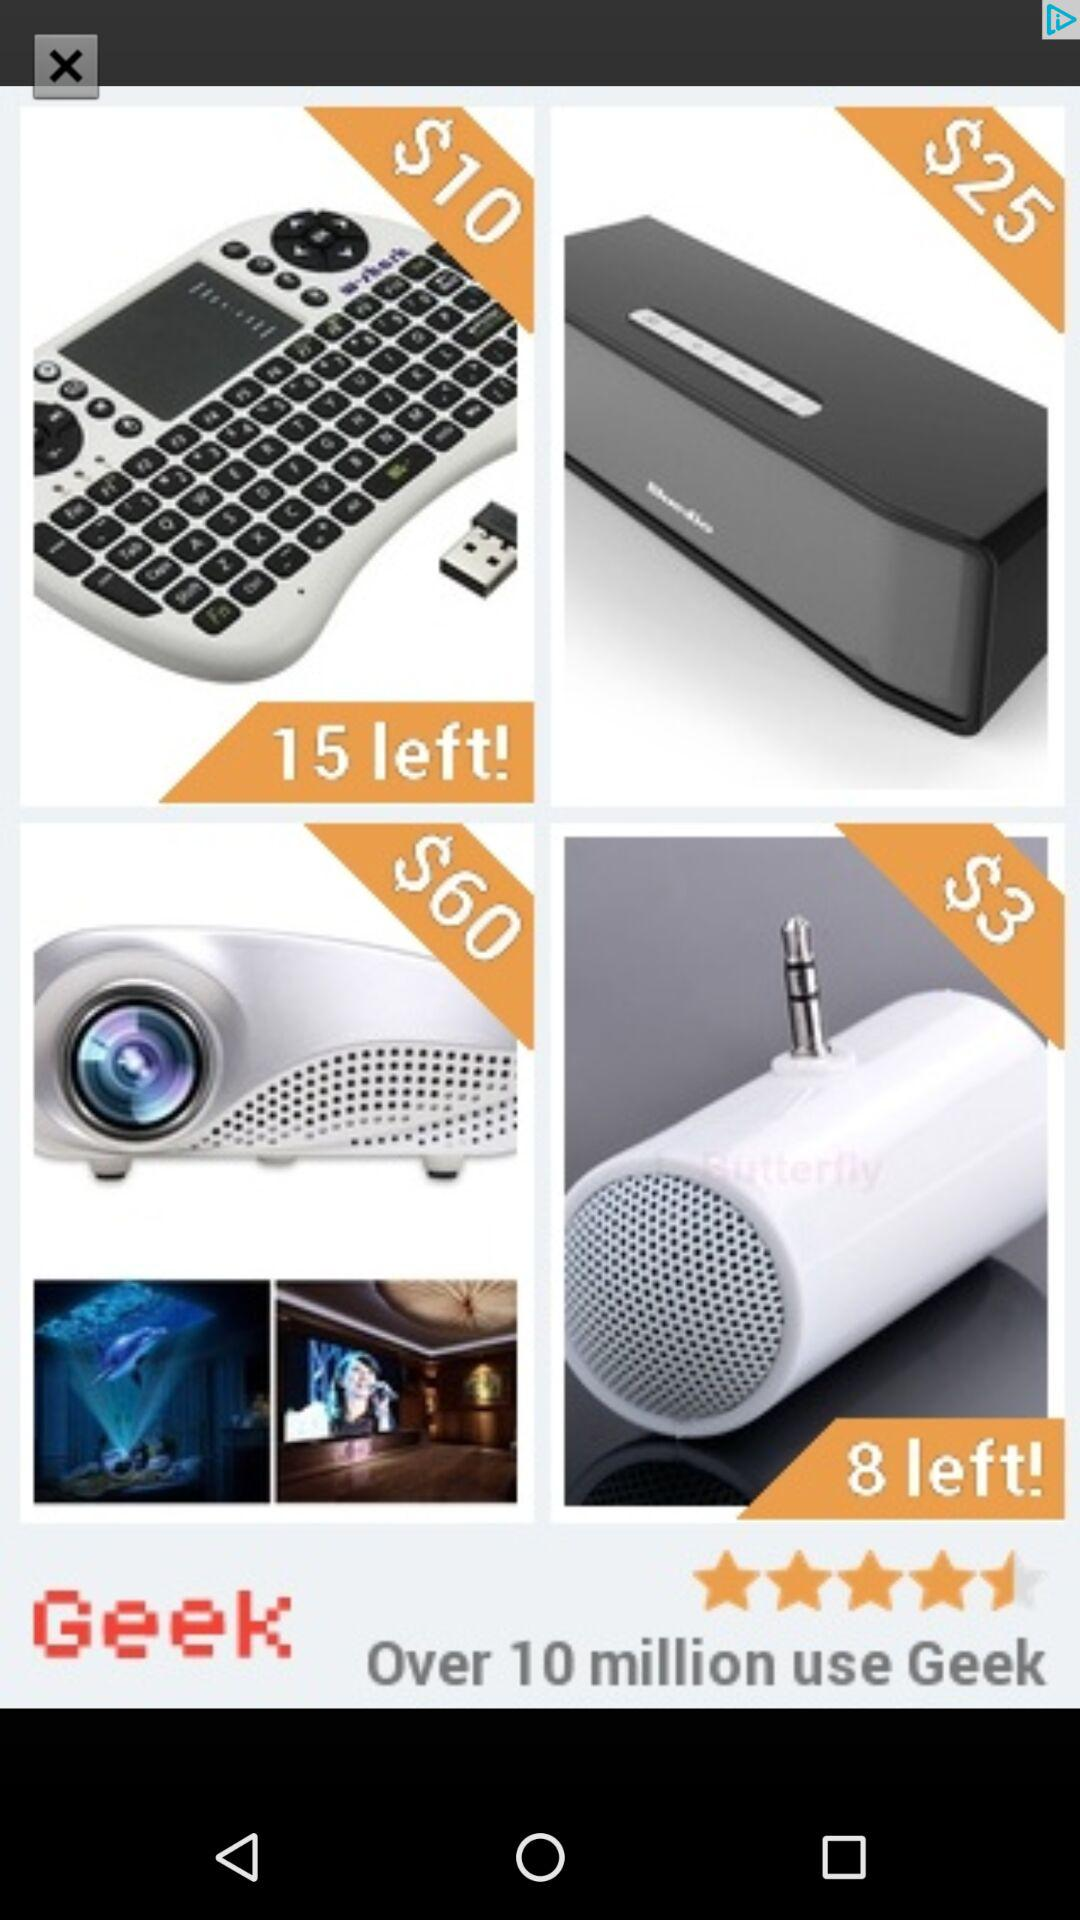How much more does the Bose Soundlink S3 cost than the keyboard?
Answer the question using a single word or phrase. $15 